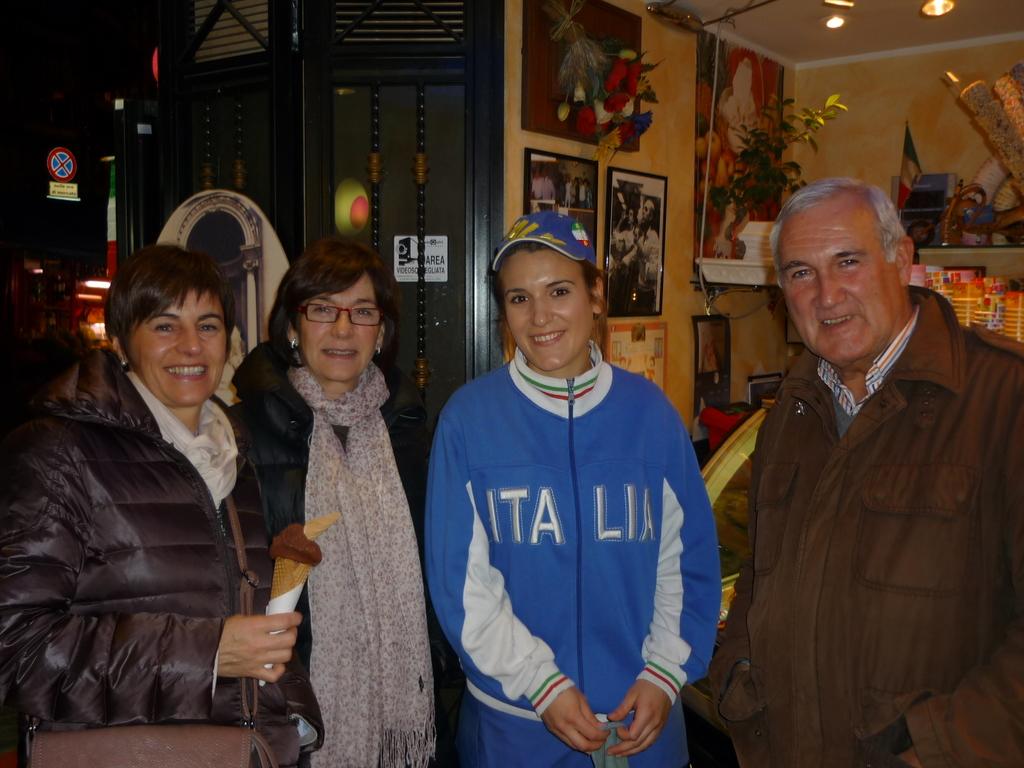What country is shown on the woman's blue jacket?
Your answer should be very brief. Italia. 